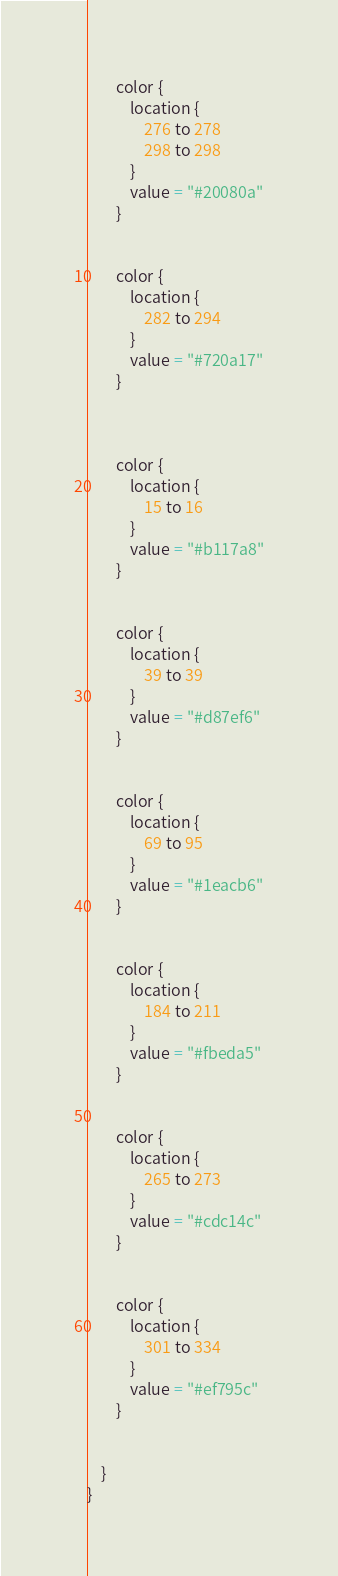Convert code to text. <code><loc_0><loc_0><loc_500><loc_500><_Kotlin_>
        color {
            location {
                276 to 278
                298 to 298
            }
            value = "#20080a"
        }


        color {
            location {
                282 to 294
            }
            value = "#720a17"
        }



        color {
            location {
                15 to 16
            }
            value = "#b117a8"
        }


        color {
            location {
                39 to 39
            }
            value = "#d87ef6"
        }


        color {
            location {
                69 to 95
            }
            value = "#1eacb6"
        }


        color {
            location {
                184 to 211
            }
            value = "#fbeda5"
        }


        color {
            location {
                265 to 273
            }
            value = "#cdc14c"
        }


        color {
            location {
                301 to 334
            }
            value = "#ef795c"
        }


    }
}           </code> 